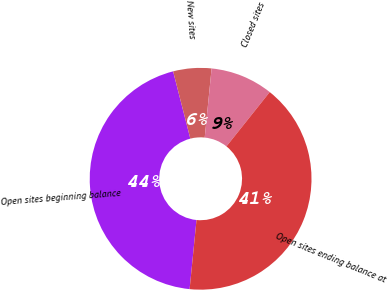<chart> <loc_0><loc_0><loc_500><loc_500><pie_chart><fcel>Open sites beginning balance<fcel>New sites<fcel>Closed sites<fcel>Open sites ending balance at<nl><fcel>44.43%<fcel>5.57%<fcel>9.13%<fcel>40.87%<nl></chart> 